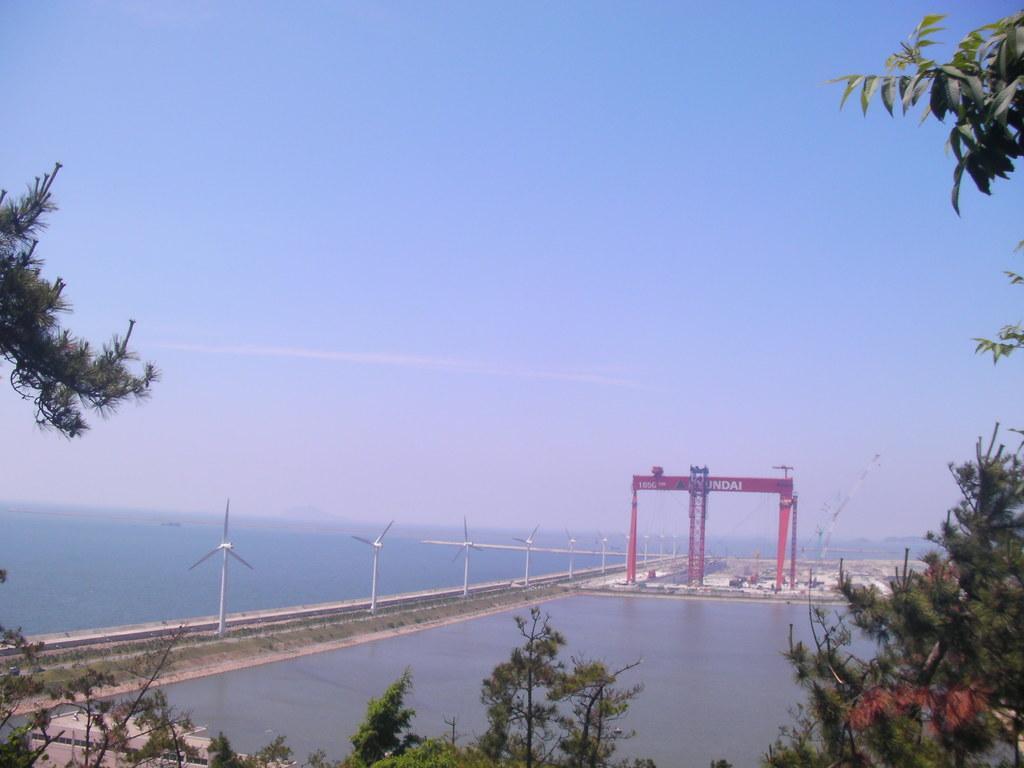Can you describe this image briefly? In this image we can see branches of trees. Also there is water. There are wind fans. In the back there is an arch with some text. In the background there is sky. 